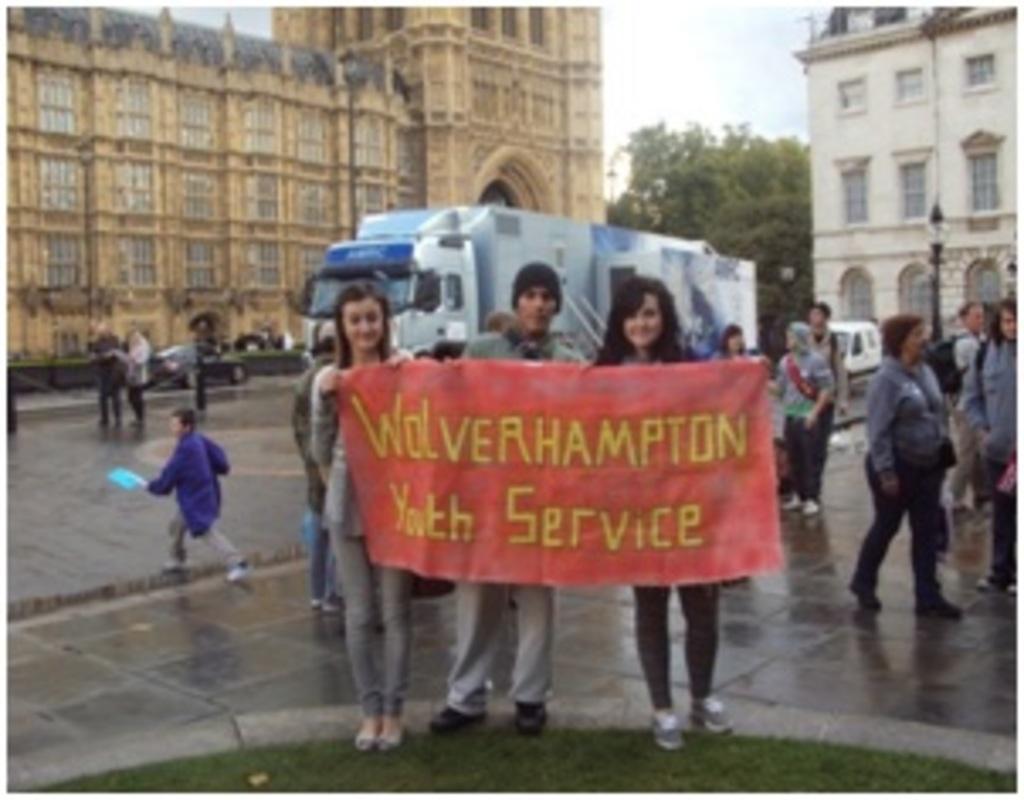Please provide a concise description of this image. In the foreground of this image, there are three persons standing and holding a banner. In the background, there are persons walking on the pavement, a vehicle, a pole and the building on the right. In the background, there is a building, a tree, sky and the cloud. 